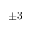Convert formula to latex. <formula><loc_0><loc_0><loc_500><loc_500>\pm 3</formula> 